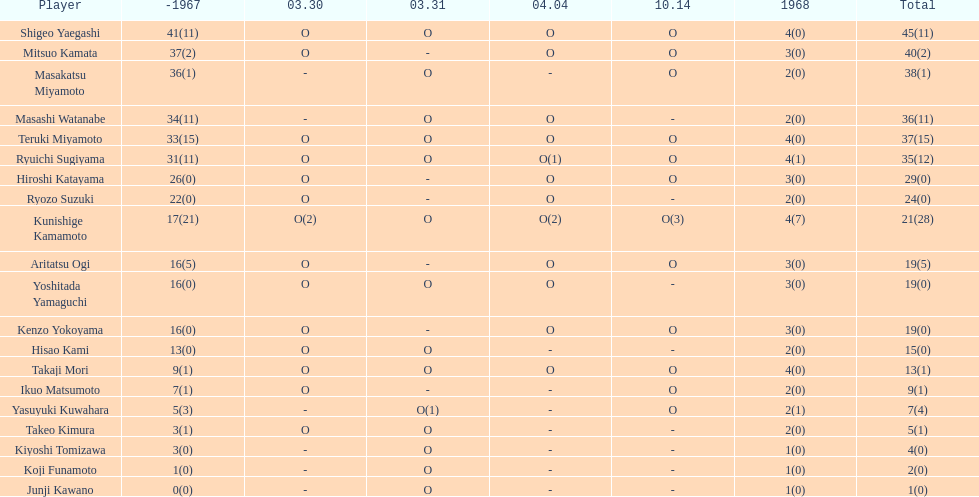During that year, what was the number of players who made an appearance? 20. 